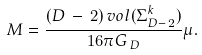<formula> <loc_0><loc_0><loc_500><loc_500>M = \frac { ( D \, - \, 2 ) \, v o l ( \Sigma _ { D - \, 2 } ^ { k } ) } { 1 6 \pi G _ { \, D } } \mu .</formula> 